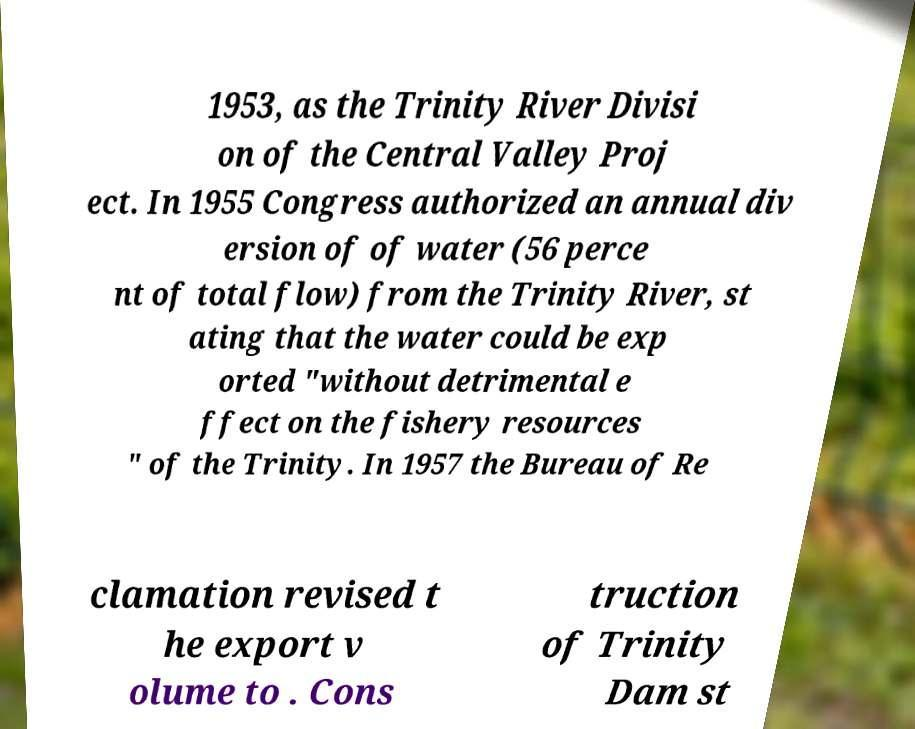Please read and relay the text visible in this image. What does it say? 1953, as the Trinity River Divisi on of the Central Valley Proj ect. In 1955 Congress authorized an annual div ersion of of water (56 perce nt of total flow) from the Trinity River, st ating that the water could be exp orted "without detrimental e ffect on the fishery resources " of the Trinity. In 1957 the Bureau of Re clamation revised t he export v olume to . Cons truction of Trinity Dam st 